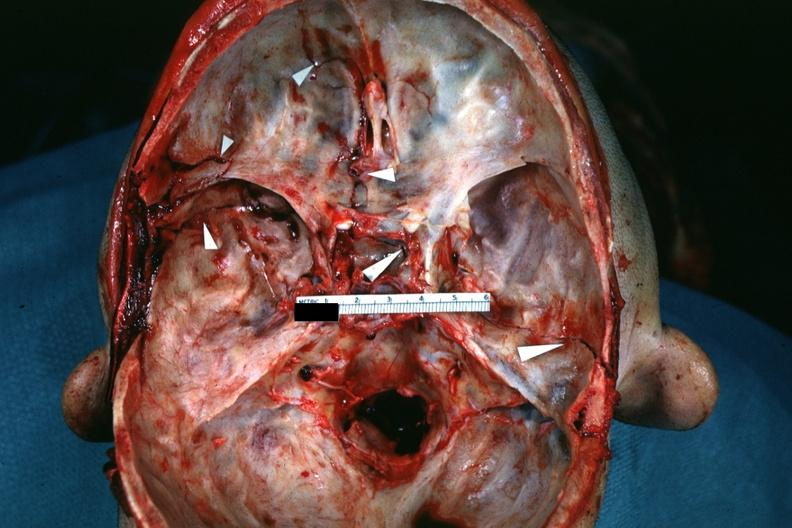does nipple duplication show fractures brain which is slide and close-up view of these fractures is slide?
Answer the question using a single word or phrase. No 